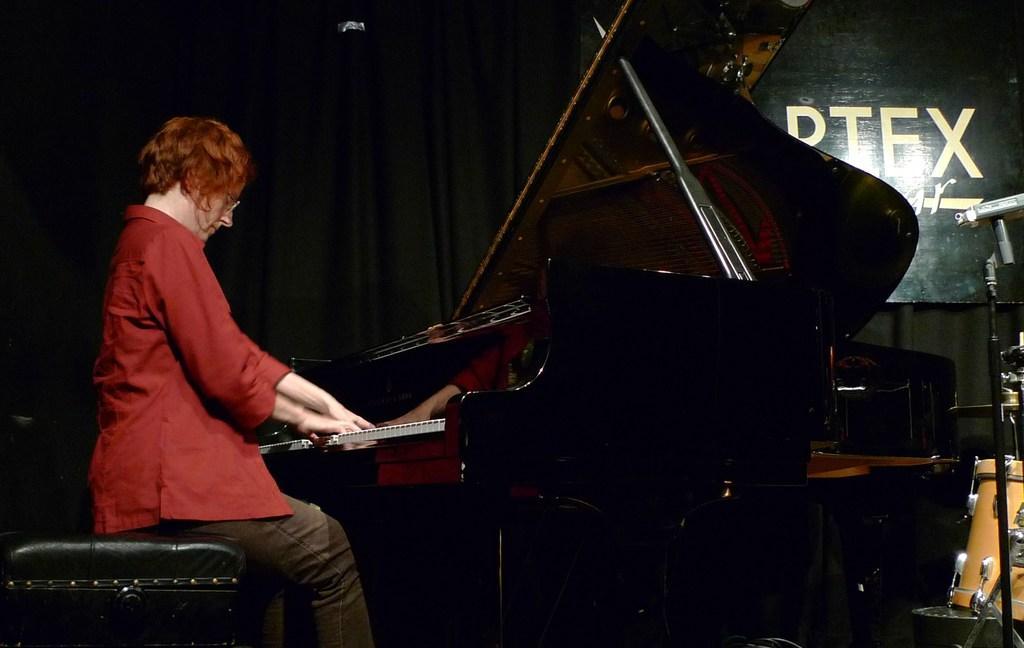Please provide a concise description of this image. She is a woman sitting on the left side. She is playing a piano. We can observe a drum on the right corner. 